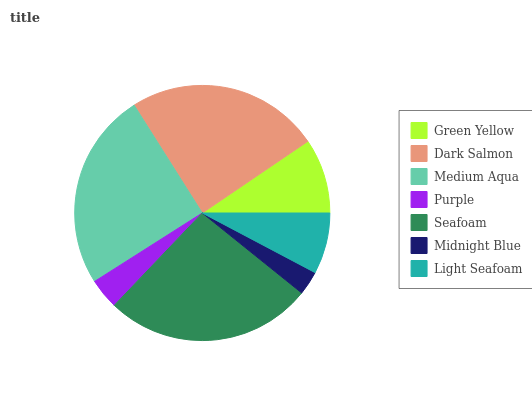Is Midnight Blue the minimum?
Answer yes or no. Yes. Is Seafoam the maximum?
Answer yes or no. Yes. Is Dark Salmon the minimum?
Answer yes or no. No. Is Dark Salmon the maximum?
Answer yes or no. No. Is Dark Salmon greater than Green Yellow?
Answer yes or no. Yes. Is Green Yellow less than Dark Salmon?
Answer yes or no. Yes. Is Green Yellow greater than Dark Salmon?
Answer yes or no. No. Is Dark Salmon less than Green Yellow?
Answer yes or no. No. Is Green Yellow the high median?
Answer yes or no. Yes. Is Green Yellow the low median?
Answer yes or no. Yes. Is Light Seafoam the high median?
Answer yes or no. No. Is Midnight Blue the low median?
Answer yes or no. No. 